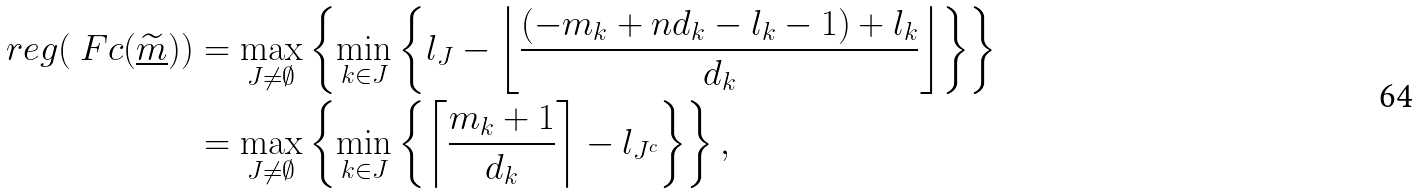<formula> <loc_0><loc_0><loc_500><loc_500>\ r e g ( \ F c ( \underline { \widetilde { m } } ) ) & = \max _ { J \ne \emptyset } \left \{ \min _ { k \in J } \left \{ l _ { J } - \left \lfloor \frac { ( - m _ { k } + n d _ { k } - l _ { k } - 1 ) + l _ { k } } { d _ { k } } \right \rfloor \right \} \right \} \\ & = \max _ { J \ne \emptyset } \left \{ \min _ { k \in J } \left \{ \left \lceil \frac { m _ { k } + 1 } { d _ { k } } \right \rceil - l _ { J ^ { c } } \right \} \right \} ,</formula> 